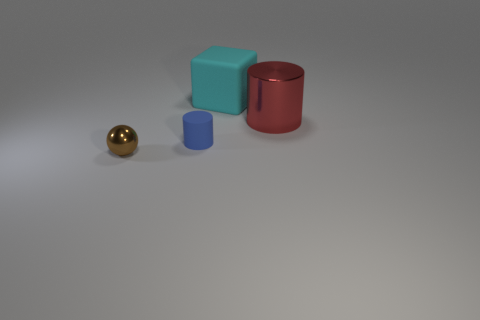There is a small thing that is behind the small metallic object; does it have the same shape as the small brown object?
Your answer should be compact. No. Are there any metal balls behind the blue matte cylinder?
Provide a short and direct response. No. What number of large things are either red things or blue metal cylinders?
Keep it short and to the point. 1. Does the small brown thing have the same material as the large red thing?
Make the answer very short. Yes. Are there any other big things that have the same color as the large shiny thing?
Offer a terse response. No. There is a blue cylinder that is made of the same material as the large cyan object; what size is it?
Ensure brevity in your answer.  Small. What is the shape of the matte object in front of the metallic object that is behind the small object left of the blue thing?
Provide a short and direct response. Cylinder. There is another object that is the same shape as the red metallic thing; what is its size?
Your answer should be compact. Small. How big is the object that is both behind the brown shiny object and to the left of the cyan rubber thing?
Provide a short and direct response. Small. What color is the sphere?
Your answer should be very brief. Brown. 